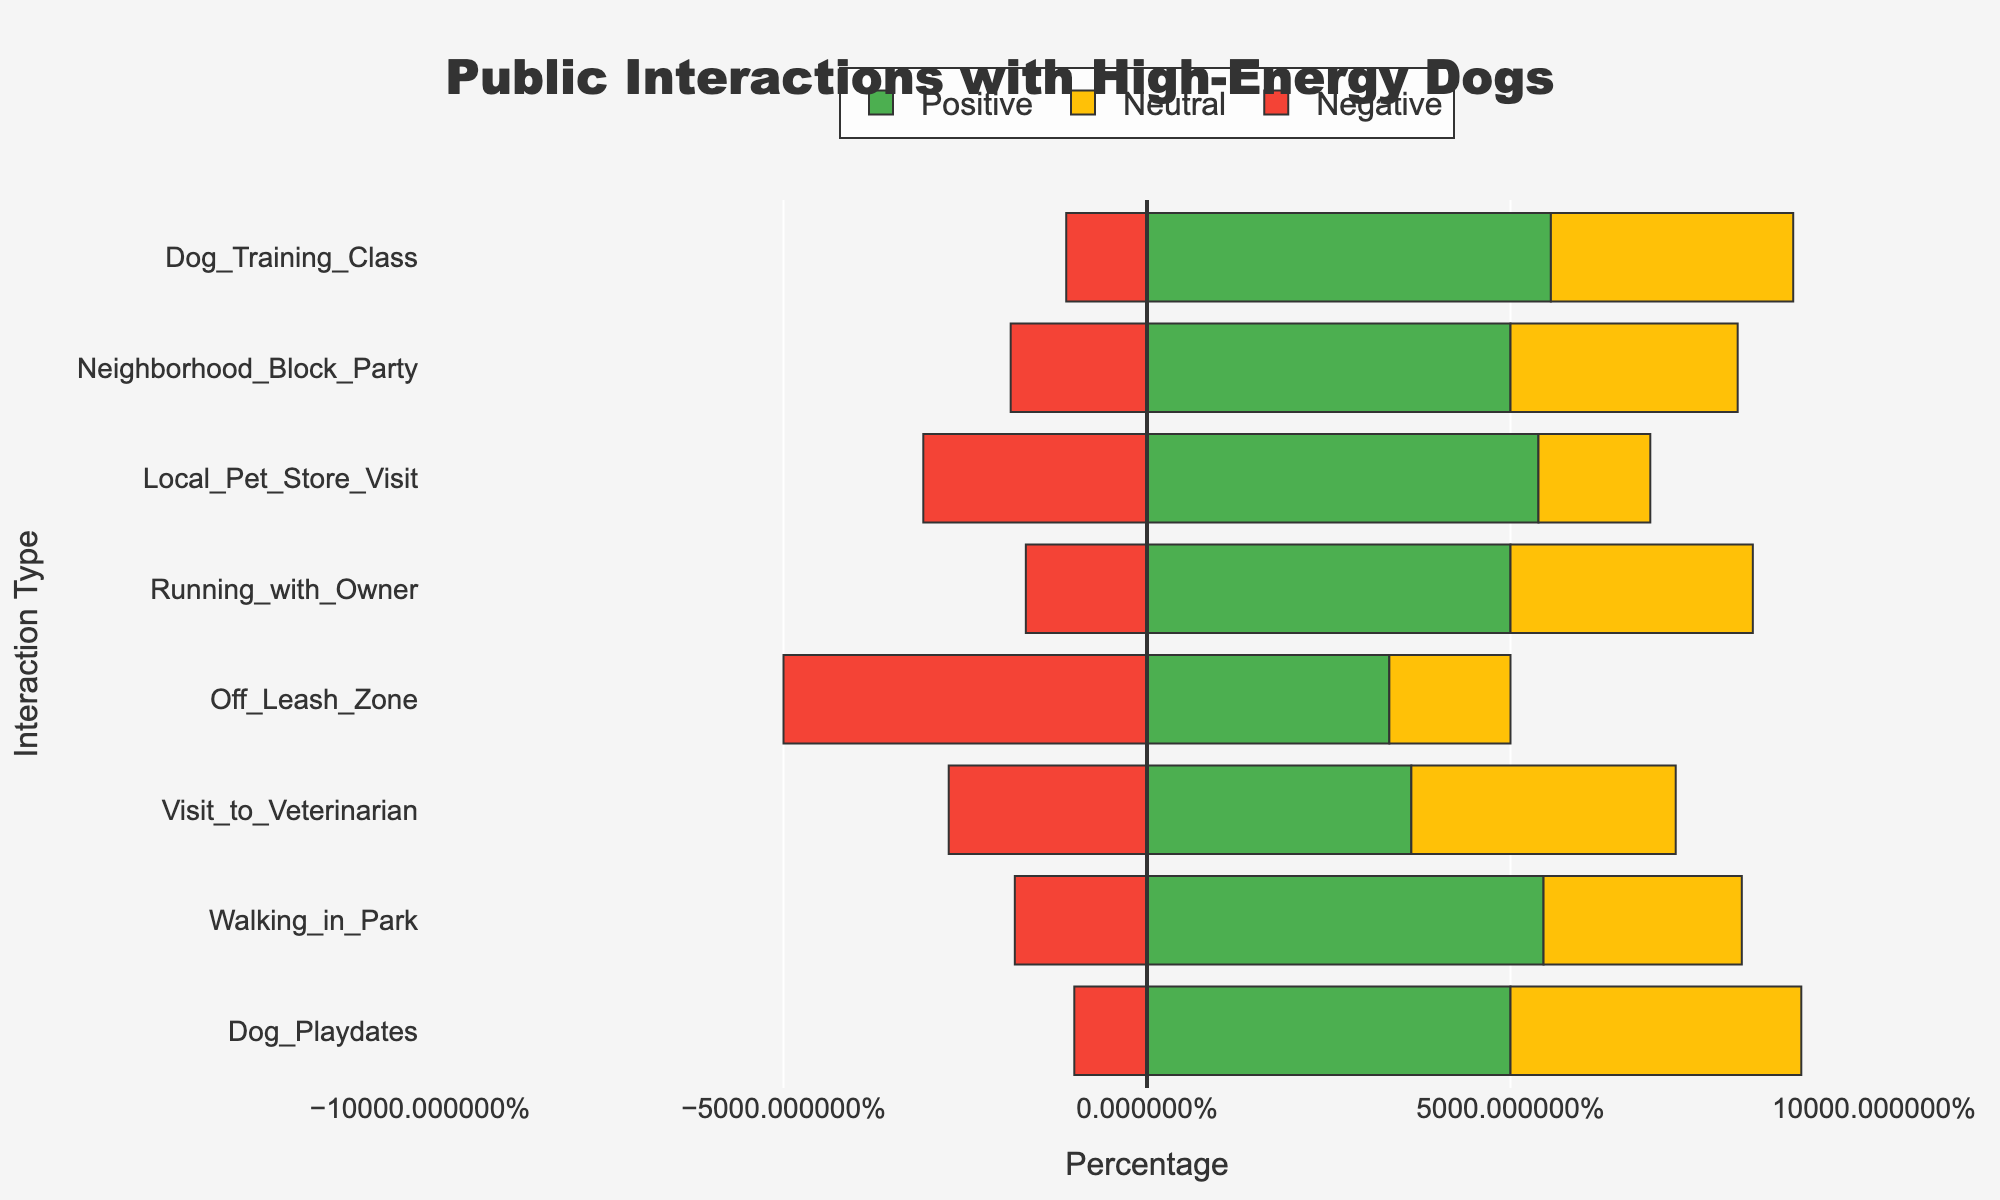What interaction type has the highest percentage of positive outcomes? The bar chart shows positivity percentages for different interactions in green. The interaction with the longest green bar indicates the highest percentage of positive outcomes. For "Dog Training Class," the green bar is the longest.
Answer: Dog Training Class Which interaction type has the highest percentage of negative outcomes? Negative outcomes are shown in red with negative percentages. The interaction with the longest red bar represents the highest percentage of negative outcomes. The "Off Leash Zone" shows the longest red bar.
Answer: Off Leash Zone How does the percentage of neutral outcomes in Neighborhood Block Party compare to that in Local Pet Store Visit? Neutral outcomes are shown in yellow. Compare the lengths of the yellow bars for "Neighborhood Block Party" and "Local Pet Store Visit." The yellow bar for "Neighborhood Block Party" is longer than for "Local Pet Store Visit."
Answer: Neighborhood Block Party has a higher percentage of neutral outcomes Which interaction types have more positive than negative outcomes? Interactions where the green bar (positive) is longer than the red bar (negative) have more positive than negative outcomes. This applies to “Walking in Park,” “Dog Playdates,” “Neighborhood Block Party,” “Local Pet Store Visit,” “Dog Training Class,” “Running with Owner,” and “Visit to Veterinarian.”
Answer: Walking in Park, Dog Playdates, Neighborhood Block Party, Local Pet Store Visit, Dog Training Class, Running with Owner, Visit to Veterinarian What is the total percentage of positive and neutral outcomes in Dog Training Class? Add the green bar (positive) percentage to the yellow bar (neutral) percentage for "Dog Training Class." The positive is 50% and the neutral is 30%. So, 50% + 30% = 80%.
Answer: 80% Compare the percentage of positive outcomes in Running with Owner to Off Leash Zone. Observe the green bars for "Running with Owner" and "Off Leash Zone." "Running with Owner" has a longer green bar at 30%, while "Off Leash Zone" is shorter at 20%.
Answer: Running with Owner has a higher percentage of positive outcomes What is the difference in the negative outcome percentage between Walking in Park and Off Leash Zone? Find the red bar lengths (negative percentages) for “Walking in Park” and “Off Leash Zone.” Subtract Walking in Park (10%) from Off Leash Zone (30%). So, 30% - 10% = 20%.
Answer: 20% Are there more positive interactions in Dog Playdates or Local Pet Store Visit? Compare the green bars for "Dog Playdates" and "Local Pet Store Visit." "Local Pet Store Visit" has a longer green bar indicating 35%, while "Dog Playdates" shows 25%.
Answer: Local Pet Store Visit Is the percentage of neutral outcomes higher in Running with Owner or Visit to Veterinarian? Compare the yellow bars for "Running with Owner" and "Visit to Veterinarian." Running with Owner has a yellow bar indicating 20%, while Visit to Veterinarian is also 20%.
Answer: Equal 